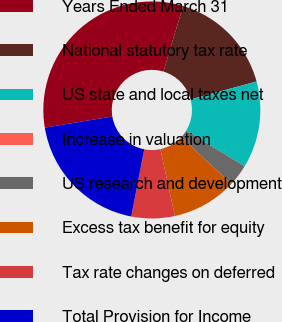Convert chart to OTSL. <chart><loc_0><loc_0><loc_500><loc_500><pie_chart><fcel>Years Ended March 31<fcel>National statutory tax rate<fcel>US state and local taxes net<fcel>Increase in valuation<fcel>US research and development<fcel>Excess tax benefit for equity<fcel>Tax rate changes on deferred<fcel>Total Provision for Income<nl><fcel>32.25%<fcel>16.13%<fcel>12.9%<fcel>0.01%<fcel>3.23%<fcel>9.68%<fcel>6.45%<fcel>19.35%<nl></chart> 